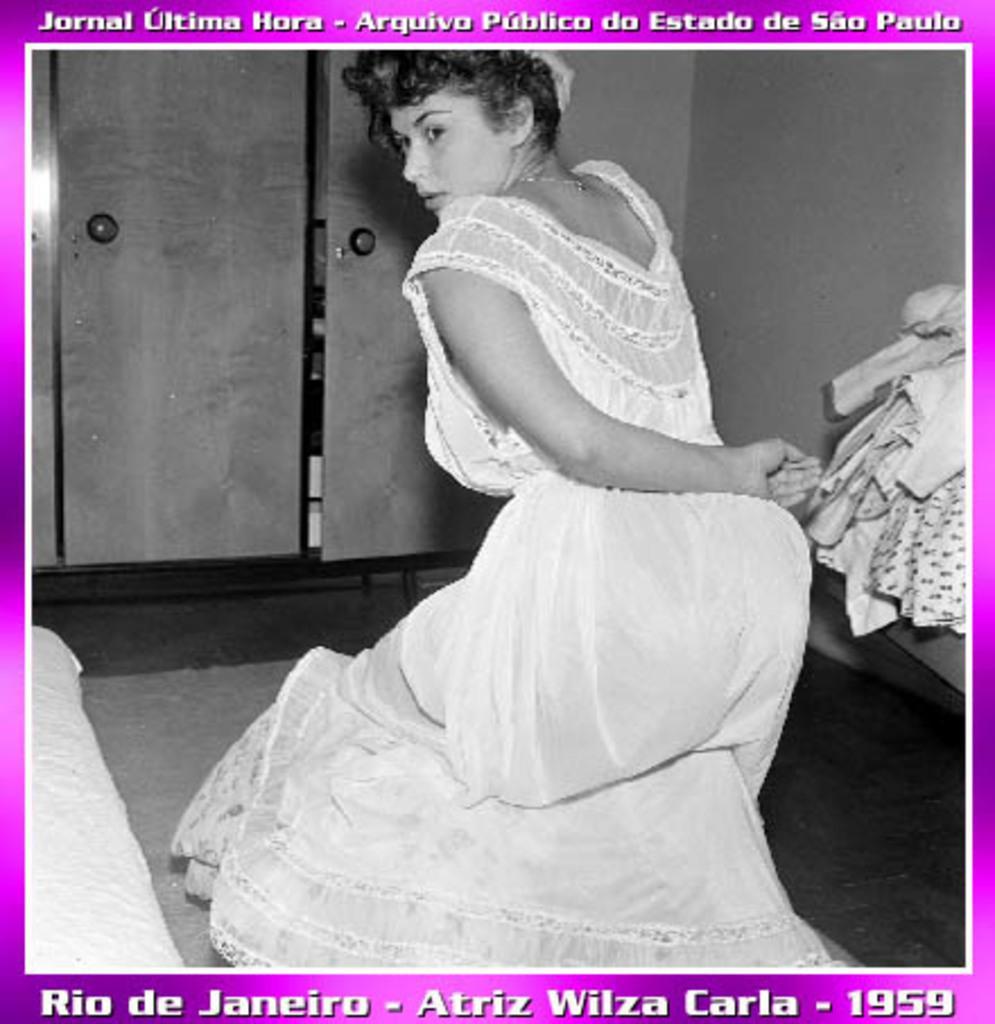How would you summarize this image in a sentence or two? In this picture there is a girl in the center of the image, it seems to be she is dancing, there are clothes on the right side of the image and there are cupboards in the background area of the image, there is bed on the left side of the image. 